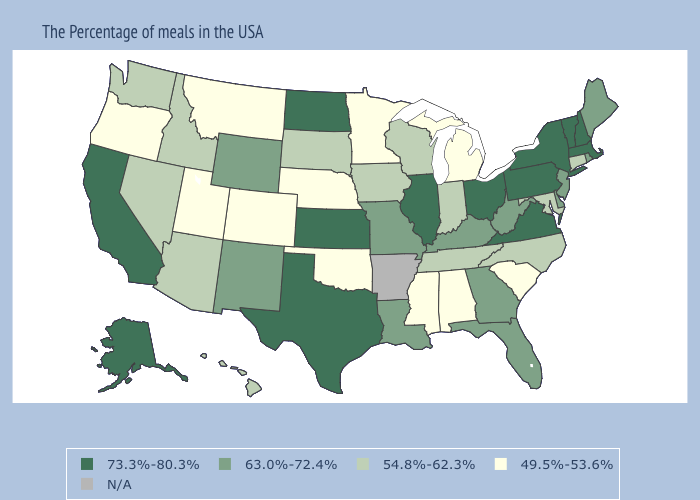What is the value of Indiana?
Concise answer only. 54.8%-62.3%. Which states have the lowest value in the USA?
Give a very brief answer. South Carolina, Michigan, Alabama, Mississippi, Minnesota, Nebraska, Oklahoma, Colorado, Utah, Montana, Oregon. Which states have the lowest value in the USA?
Give a very brief answer. South Carolina, Michigan, Alabama, Mississippi, Minnesota, Nebraska, Oklahoma, Colorado, Utah, Montana, Oregon. Name the states that have a value in the range 49.5%-53.6%?
Quick response, please. South Carolina, Michigan, Alabama, Mississippi, Minnesota, Nebraska, Oklahoma, Colorado, Utah, Montana, Oregon. What is the highest value in the Northeast ?
Write a very short answer. 73.3%-80.3%. Does the map have missing data?
Quick response, please. Yes. Does North Carolina have the highest value in the USA?
Concise answer only. No. Among the states that border Montana , does North Dakota have the lowest value?
Keep it brief. No. Name the states that have a value in the range 54.8%-62.3%?
Be succinct. Connecticut, Maryland, North Carolina, Indiana, Tennessee, Wisconsin, Iowa, South Dakota, Arizona, Idaho, Nevada, Washington, Hawaii. Does Kentucky have the highest value in the USA?
Write a very short answer. No. Among the states that border Idaho , which have the lowest value?
Write a very short answer. Utah, Montana, Oregon. What is the value of Colorado?
Answer briefly. 49.5%-53.6%. Name the states that have a value in the range 54.8%-62.3%?
Give a very brief answer. Connecticut, Maryland, North Carolina, Indiana, Tennessee, Wisconsin, Iowa, South Dakota, Arizona, Idaho, Nevada, Washington, Hawaii. 